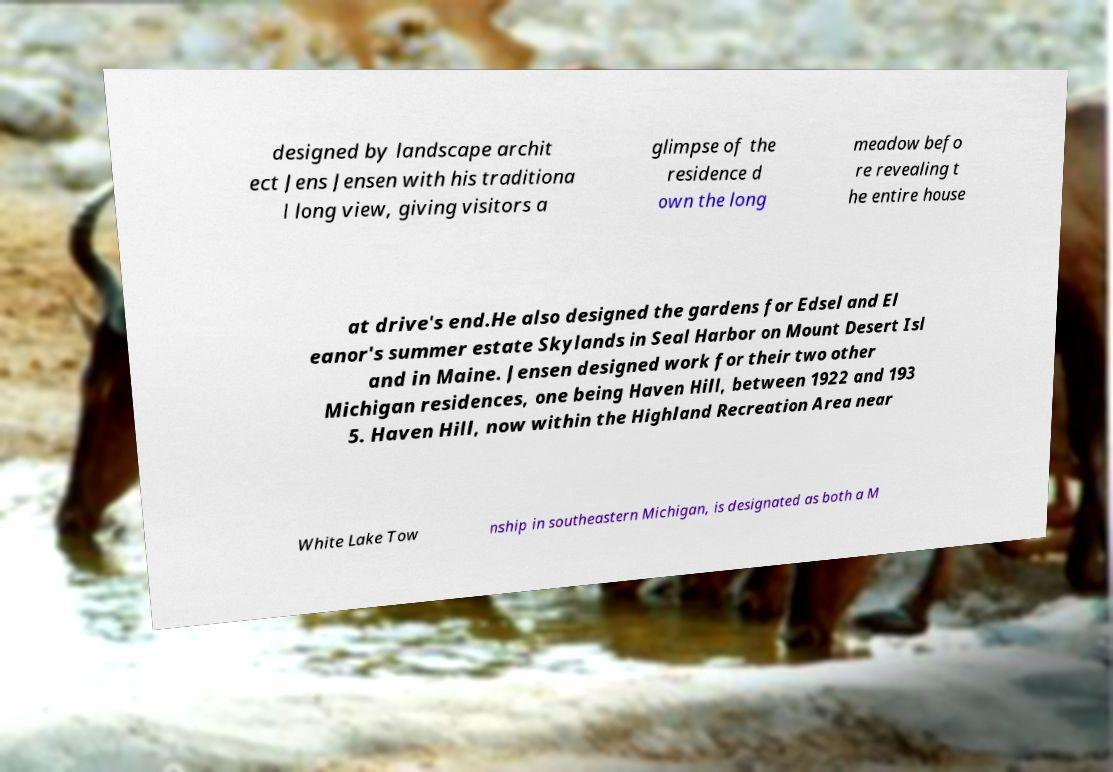Could you assist in decoding the text presented in this image and type it out clearly? designed by landscape archit ect Jens Jensen with his traditiona l long view, giving visitors a glimpse of the residence d own the long meadow befo re revealing t he entire house at drive's end.He also designed the gardens for Edsel and El eanor's summer estate Skylands in Seal Harbor on Mount Desert Isl and in Maine. Jensen designed work for their two other Michigan residences, one being Haven Hill, between 1922 and 193 5. Haven Hill, now within the Highland Recreation Area near White Lake Tow nship in southeastern Michigan, is designated as both a M 